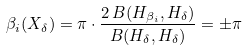<formula> <loc_0><loc_0><loc_500><loc_500>\beta _ { i } ( X _ { \delta } ) = \pi \cdot \frac { 2 \, B ( H _ { \beta _ { i } } , H _ { \delta } ) } { B ( H _ { \delta } , H _ { \delta } ) } = \pm \pi</formula> 